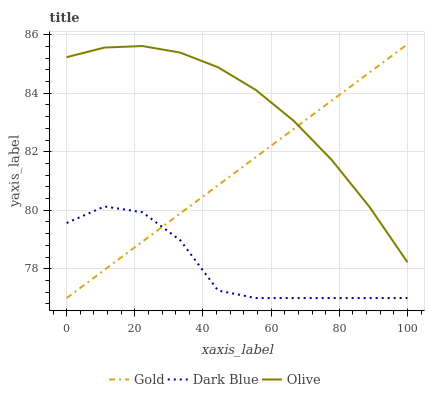Does Dark Blue have the minimum area under the curve?
Answer yes or no. Yes. Does Olive have the maximum area under the curve?
Answer yes or no. Yes. Does Gold have the minimum area under the curve?
Answer yes or no. No. Does Gold have the maximum area under the curve?
Answer yes or no. No. Is Gold the smoothest?
Answer yes or no. Yes. Is Dark Blue the roughest?
Answer yes or no. Yes. Is Dark Blue the smoothest?
Answer yes or no. No. Is Gold the roughest?
Answer yes or no. No. Does Dark Blue have the lowest value?
Answer yes or no. Yes. Does Gold have the highest value?
Answer yes or no. Yes. Does Dark Blue have the highest value?
Answer yes or no. No. Is Dark Blue less than Olive?
Answer yes or no. Yes. Is Olive greater than Dark Blue?
Answer yes or no. Yes. Does Olive intersect Gold?
Answer yes or no. Yes. Is Olive less than Gold?
Answer yes or no. No. Is Olive greater than Gold?
Answer yes or no. No. Does Dark Blue intersect Olive?
Answer yes or no. No. 